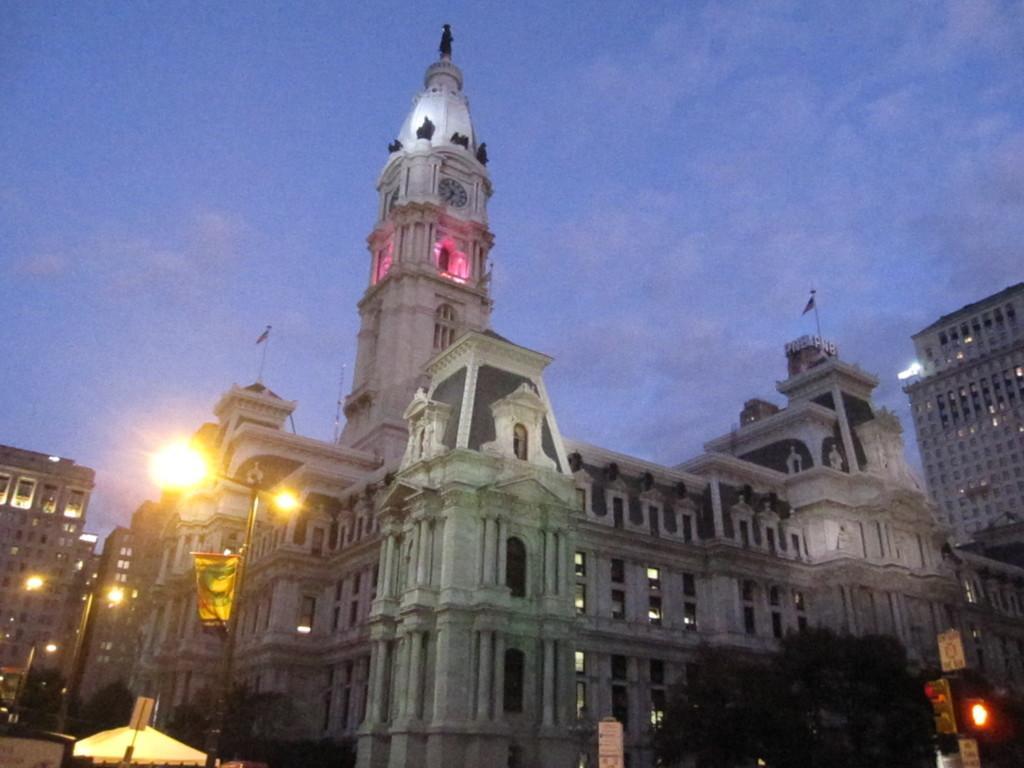In one or two sentences, can you explain what this image depicts? In the center of the image we can see buildings, lights, pole, board, flags. At the bottom of the image we can see tent, boards, traffic lights, trees. At the top of the image clouds are present in the sky. 